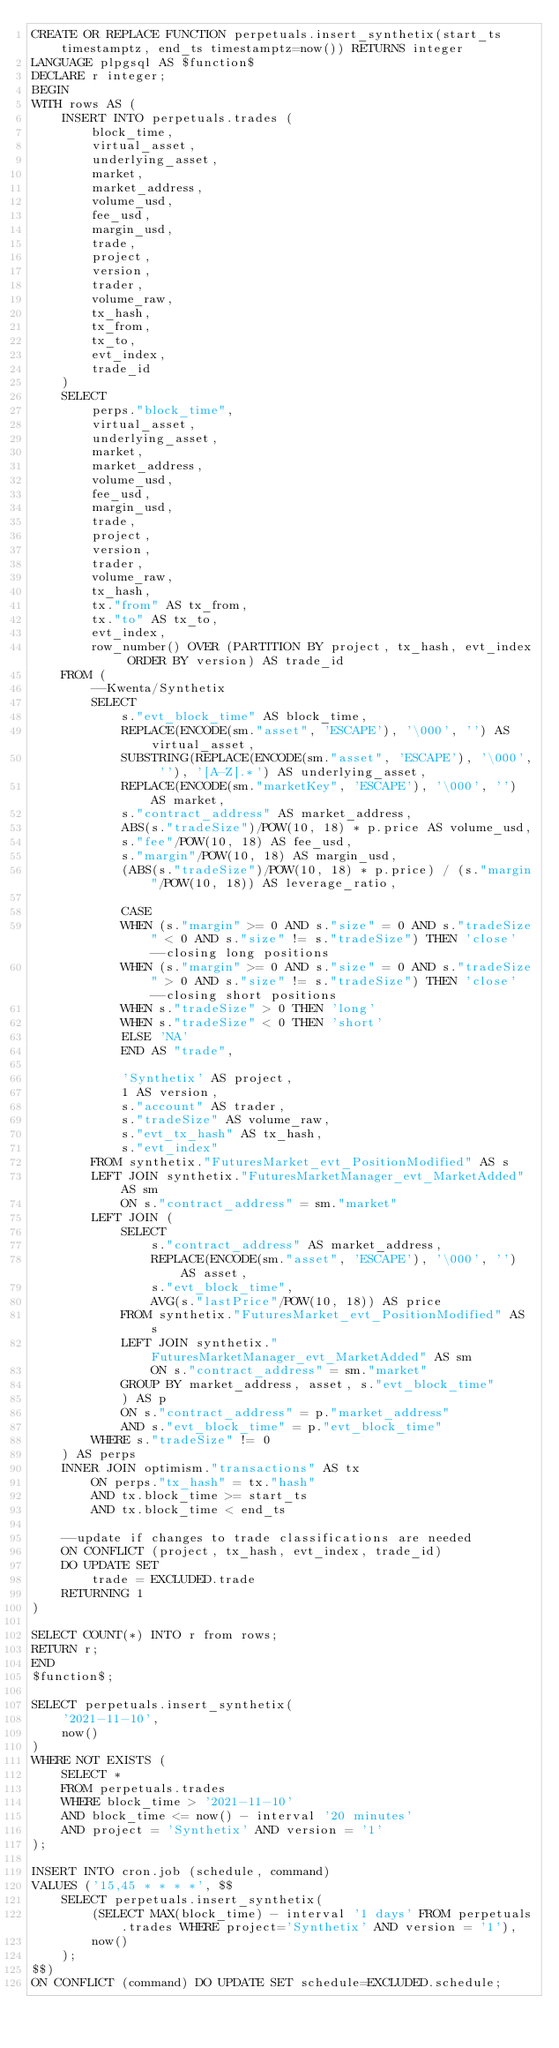Convert code to text. <code><loc_0><loc_0><loc_500><loc_500><_SQL_>CREATE OR REPLACE FUNCTION perpetuals.insert_synthetix(start_ts timestamptz, end_ts timestamptz=now()) RETURNS integer
LANGUAGE plpgsql AS $function$
DECLARE r integer;
BEGIN
WITH rows AS (
    INSERT INTO perpetuals.trades (
        block_time,
        virtual_asset,
        underlying_asset,
        market,
        market_address,
        volume_usd,
        fee_usd,
        margin_usd,
        trade,
        project,
        version,
        trader,
        volume_raw,
        tx_hash,
        tx_from,
        tx_to,
        evt_index,
        trade_id
    )
    SELECT
        perps."block_time",
        virtual_asset,
        underlying_asset,
        market,
        market_address,
        volume_usd,
        fee_usd,
        margin_usd,
        trade,
        project,
        version,
        trader,
        volume_raw,
        tx_hash,
        tx."from" AS tx_from,
        tx."to" AS tx_to,
        evt_index,
        row_number() OVER (PARTITION BY project, tx_hash, evt_index ORDER BY version) AS trade_id
    FROM (
        --Kwenta/Synthetix
        SELECT
            s."evt_block_time" AS block_time,
            REPLACE(ENCODE(sm."asset", 'ESCAPE'), '\000', '') AS virtual_asset,
            SUBSTRING(REPLACE(ENCODE(sm."asset", 'ESCAPE'), '\000', ''), '[A-Z].*') AS underlying_asset,
            REPLACE(ENCODE(sm."marketKey", 'ESCAPE'), '\000', '') AS market,
            s."contract_address" AS market_address,
            ABS(s."tradeSize")/POW(10, 18) * p.price AS volume_usd,
            s."fee"/POW(10, 18) AS fee_usd,
            s."margin"/POW(10, 18) AS margin_usd,
            (ABS(s."tradeSize")/POW(10, 18) * p.price) / (s."margin"/POW(10, 18)) AS leverage_ratio,
            
            CASE
            WHEN (s."margin" >= 0 AND s."size" = 0 AND s."tradeSize" < 0 AND s."size" != s."tradeSize") THEN 'close' --closing long positions
            WHEN (s."margin" >= 0 AND s."size" = 0 AND s."tradeSize" > 0 AND s."size" != s."tradeSize") THEN 'close' --closing short positions
            WHEN s."tradeSize" > 0 THEN 'long'
            WHEN s."tradeSize" < 0 THEN 'short'
            ELSE 'NA'
            END AS "trade",
            
            'Synthetix' AS project,
            1 AS version,
            s."account" AS trader,
            s."tradeSize" AS volume_raw,
            s."evt_tx_hash" AS tx_hash,
            s."evt_index"
        FROM synthetix."FuturesMarket_evt_PositionModified" AS s
        LEFT JOIN synthetix."FuturesMarketManager_evt_MarketAdded" AS sm
            ON s."contract_address" = sm."market"
        LEFT JOIN (
            SELECT
                s."contract_address" AS market_address,
                REPLACE(ENCODE(sm."asset", 'ESCAPE'), '\000', '') AS asset,
                s."evt_block_time",
                AVG(s."lastPrice"/POW(10, 18)) AS price
            FROM synthetix."FuturesMarket_evt_PositionModified" AS s
            LEFT JOIN synthetix."FuturesMarketManager_evt_MarketAdded" AS sm
                ON s."contract_address" = sm."market"
            GROUP BY market_address, asset, s."evt_block_time"
            ) AS p
            ON s."contract_address" = p."market_address"
            AND s."evt_block_time" = p."evt_block_time"
        WHERE s."tradeSize" != 0
    ) AS perps
    INNER JOIN optimism."transactions" AS tx
        ON perps."tx_hash" = tx."hash"
        AND tx.block_time >= start_ts
        AND tx.block_time < end_ts
    
    --update if changes to trade classifications are needed
    ON CONFLICT (project, tx_hash, evt_index, trade_id)
    DO UPDATE SET
        trade = EXCLUDED.trade
    RETURNING 1
)

SELECT COUNT(*) INTO r from rows;
RETURN r;
END
$function$;

SELECT perpetuals.insert_synthetix(
    '2021-11-10',
    now()
)
WHERE NOT EXISTS (
    SELECT *
    FROM perpetuals.trades
    WHERE block_time > '2021-11-10'
    AND block_time <= now() - interval '20 minutes'
    AND project = 'Synthetix' AND version = '1'
);

INSERT INTO cron.job (schedule, command)
VALUES ('15,45 * * * *', $$
    SELECT perpetuals.insert_synthetix(
        (SELECT MAX(block_time) - interval '1 days' FROM perpetuals.trades WHERE project='Synthetix' AND version = '1'),
        now()
    );
$$)
ON CONFLICT (command) DO UPDATE SET schedule=EXCLUDED.schedule;
</code> 